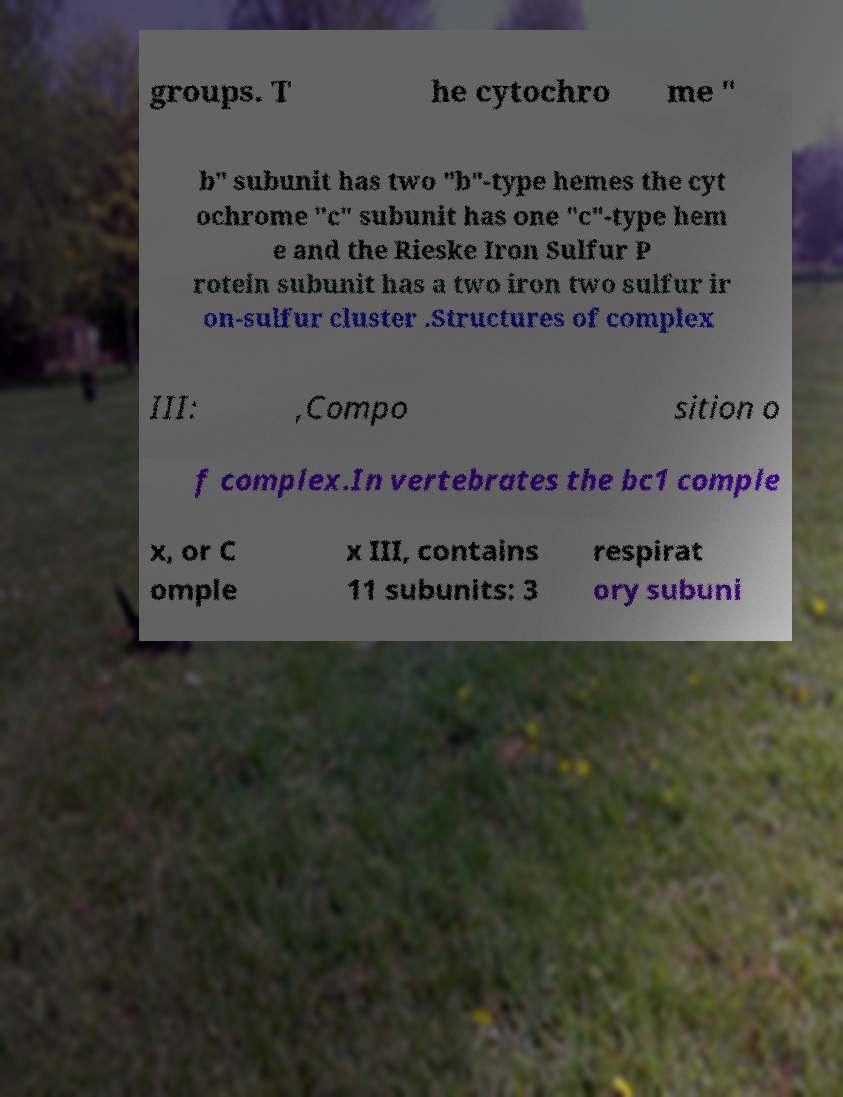Can you accurately transcribe the text from the provided image for me? groups. T he cytochro me " b" subunit has two "b"-type hemes the cyt ochrome "c" subunit has one "c"-type hem e and the Rieske Iron Sulfur P rotein subunit has a two iron two sulfur ir on-sulfur cluster .Structures of complex III: ,Compo sition o f complex.In vertebrates the bc1 comple x, or C omple x III, contains 11 subunits: 3 respirat ory subuni 